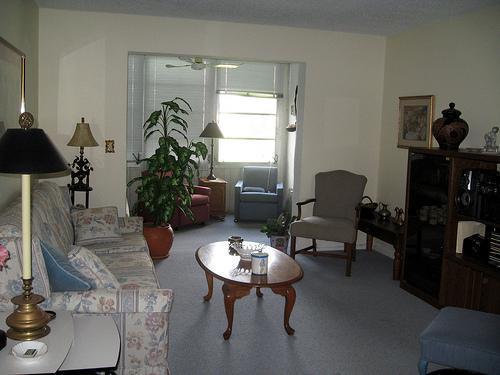How many chairs are pictured here?
Give a very brief answer. 4. 